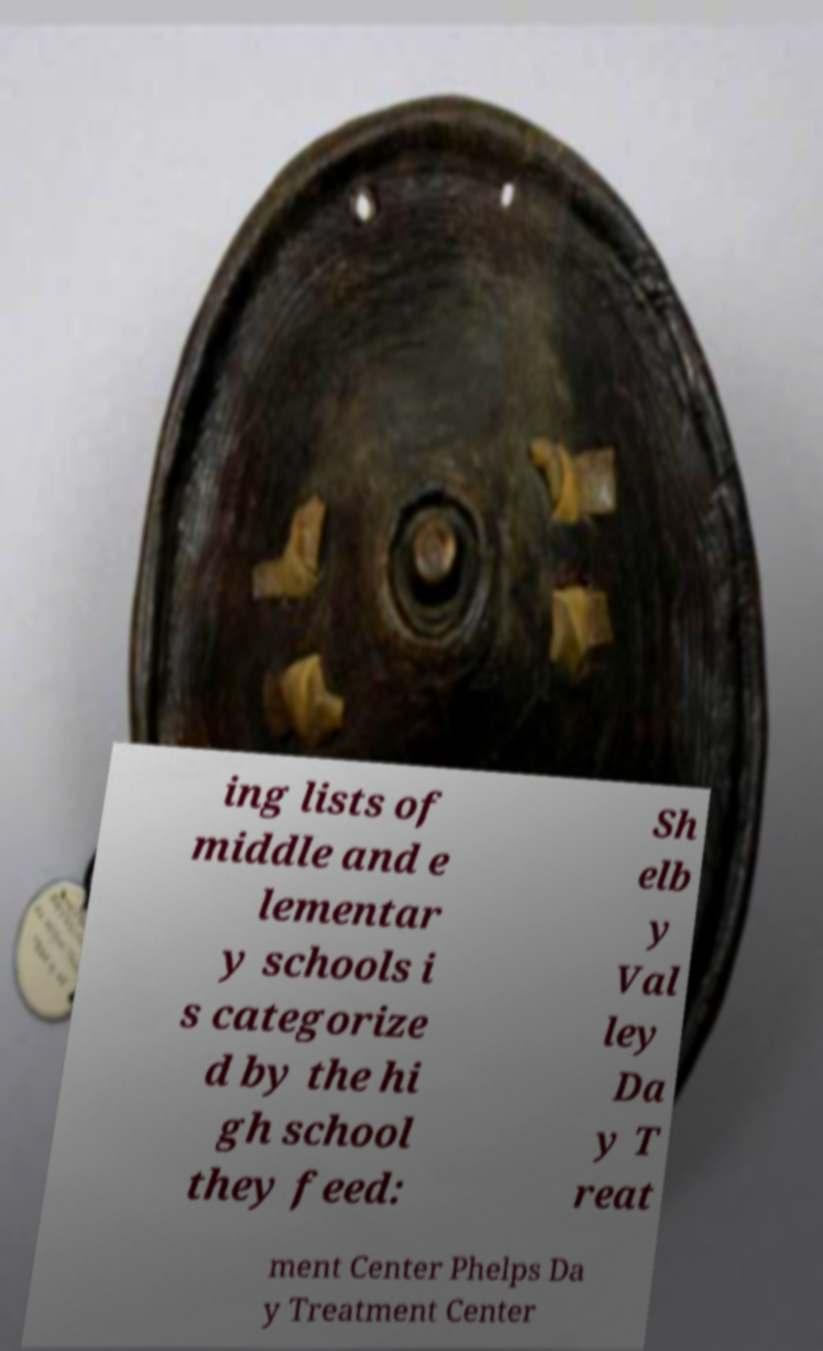For documentation purposes, I need the text within this image transcribed. Could you provide that? ing lists of middle and e lementar y schools i s categorize d by the hi gh school they feed: Sh elb y Val ley Da y T reat ment Center Phelps Da y Treatment Center 